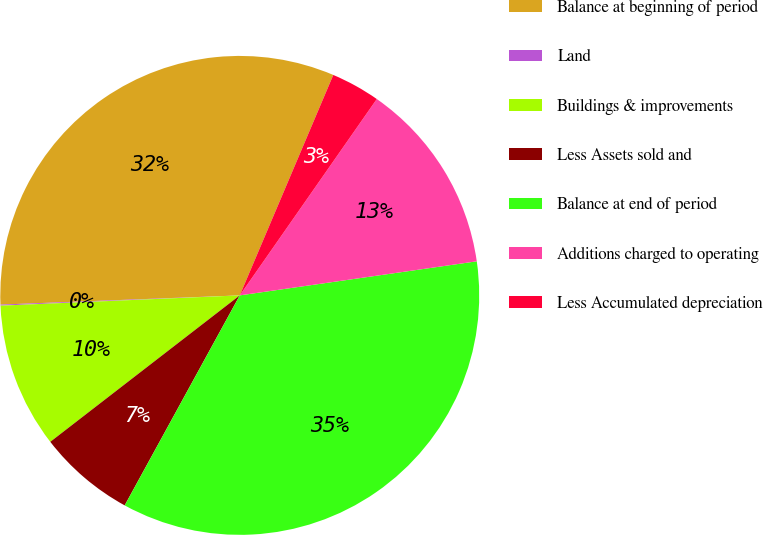<chart> <loc_0><loc_0><loc_500><loc_500><pie_chart><fcel>Balance at beginning of period<fcel>Land<fcel>Buildings & improvements<fcel>Less Assets sold and<fcel>Balance at end of period<fcel>Additions charged to operating<fcel>Less Accumulated depreciation<nl><fcel>32.0%<fcel>0.07%<fcel>9.79%<fcel>6.55%<fcel>35.25%<fcel>13.03%<fcel>3.31%<nl></chart> 